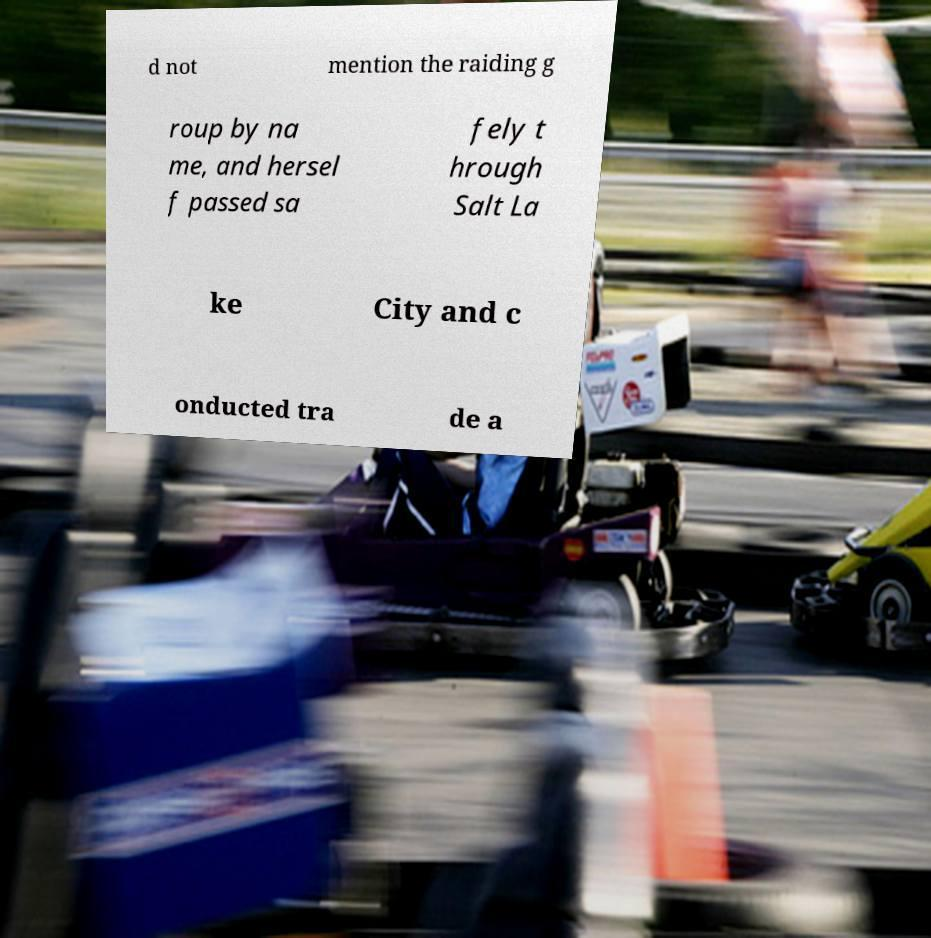Could you extract and type out the text from this image? d not mention the raiding g roup by na me, and hersel f passed sa fely t hrough Salt La ke City and c onducted tra de a 